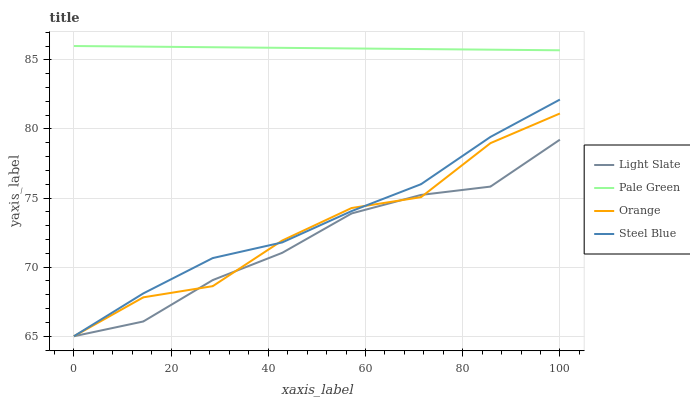Does Light Slate have the minimum area under the curve?
Answer yes or no. Yes. Does Pale Green have the maximum area under the curve?
Answer yes or no. Yes. Does Orange have the minimum area under the curve?
Answer yes or no. No. Does Orange have the maximum area under the curve?
Answer yes or no. No. Is Pale Green the smoothest?
Answer yes or no. Yes. Is Orange the roughest?
Answer yes or no. Yes. Is Orange the smoothest?
Answer yes or no. No. Is Pale Green the roughest?
Answer yes or no. No. Does Pale Green have the lowest value?
Answer yes or no. No. Does Orange have the highest value?
Answer yes or no. No. Is Orange less than Pale Green?
Answer yes or no. Yes. Is Pale Green greater than Orange?
Answer yes or no. Yes. Does Orange intersect Pale Green?
Answer yes or no. No. 